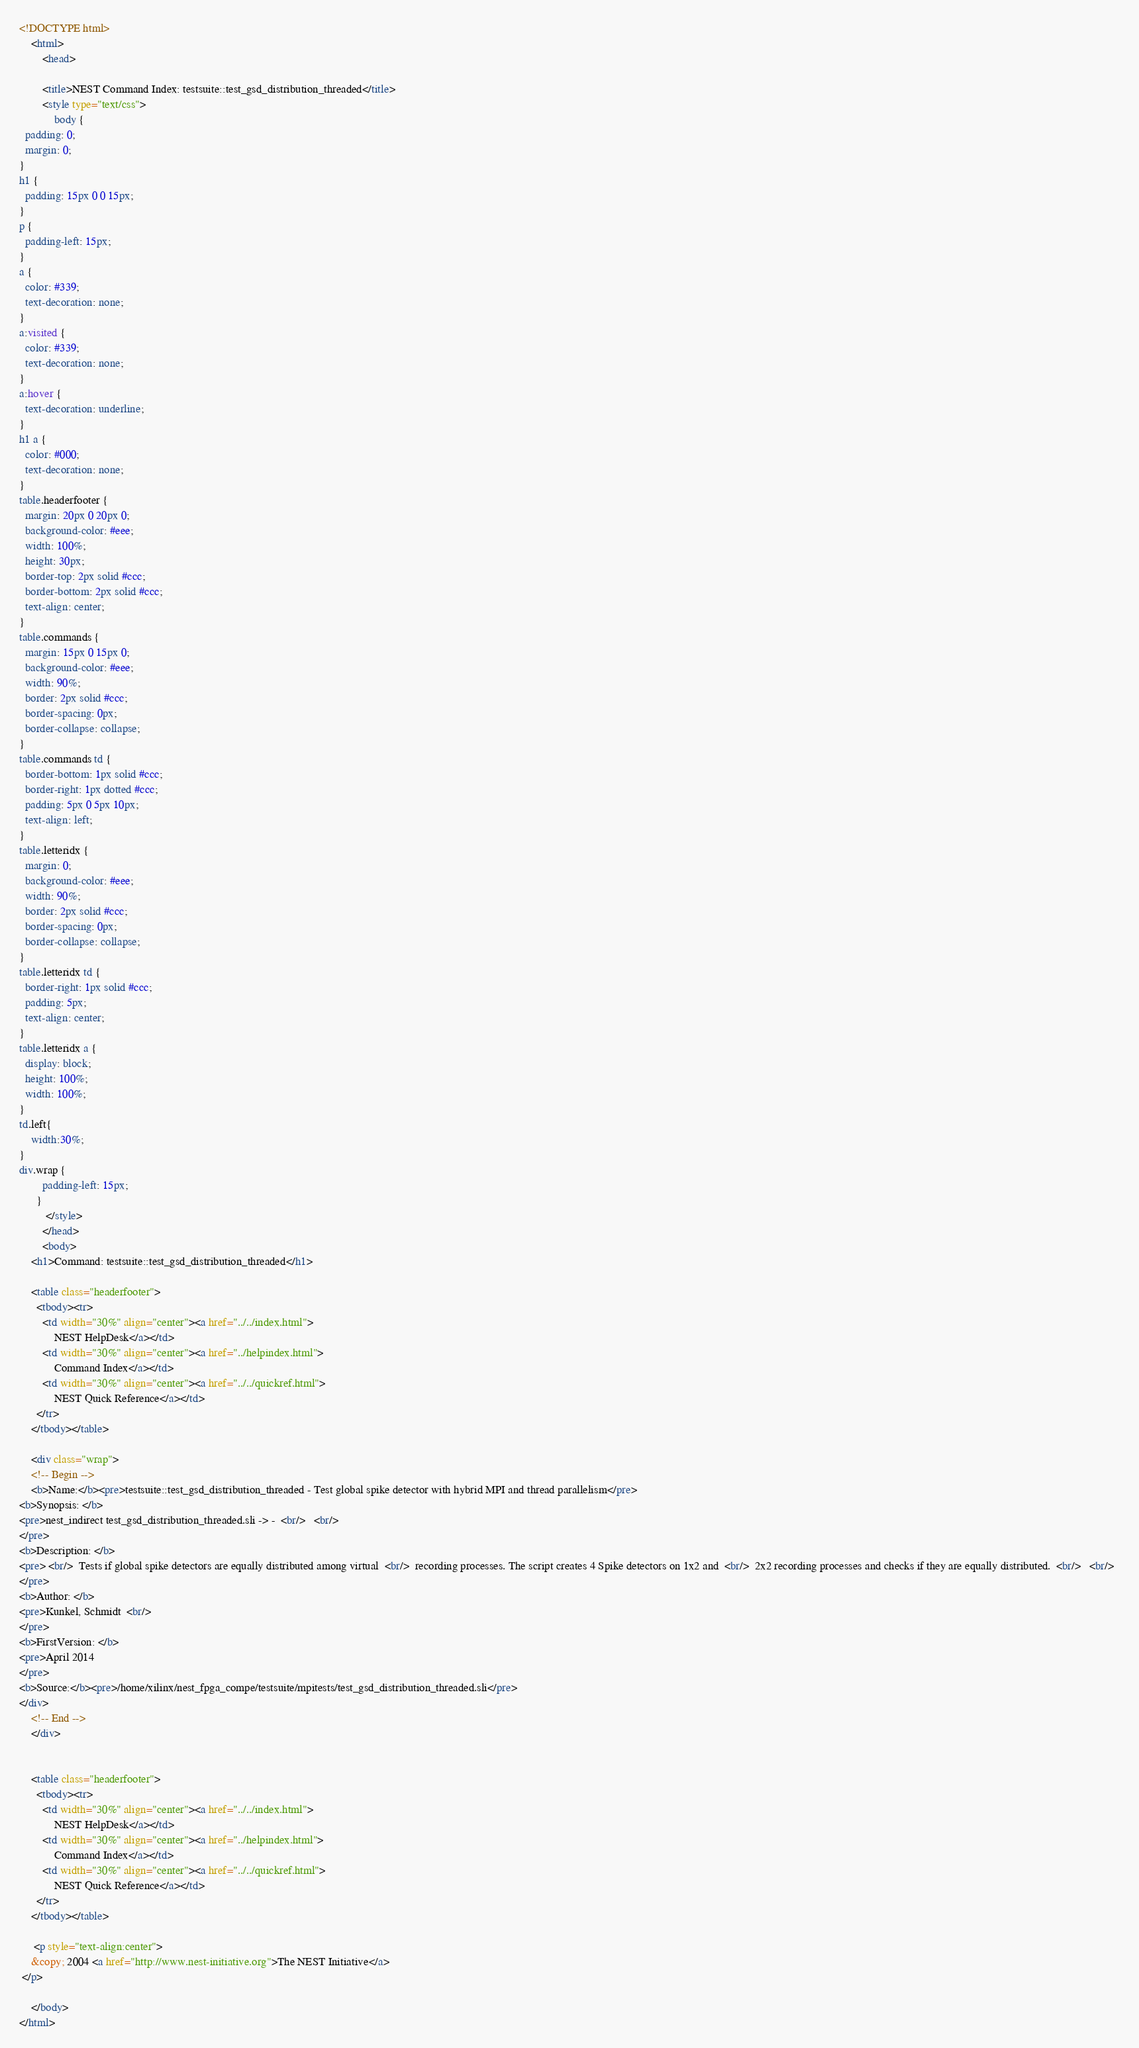Convert code to text. <code><loc_0><loc_0><loc_500><loc_500><_HTML_><!DOCTYPE html>
    <html>
        <head>
    
        <title>NEST Command Index: testsuite::test_gsd_distribution_threaded</title>
        <style type="text/css">
            body {
  padding: 0;
  margin: 0;
}
h1 {
  padding: 15px 0 0 15px;
}
p {
  padding-left: 15px;
}
a {
  color: #339;
  text-decoration: none;
}
a:visited {
  color: #339;
  text-decoration: none;
}
a:hover {
  text-decoration: underline;
}
h1 a {
  color: #000;
  text-decoration: none;
}
table.headerfooter {
  margin: 20px 0 20px 0;
  background-color: #eee;
  width: 100%;
  height: 30px;
  border-top: 2px solid #ccc;
  border-bottom: 2px solid #ccc;
  text-align: center;
}
table.commands {
  margin: 15px 0 15px 0;
  background-color: #eee;
  width: 90%;
  border: 2px solid #ccc;
  border-spacing: 0px;
  border-collapse: collapse;
}
table.commands td {
  border-bottom: 1px solid #ccc;
  border-right: 1px dotted #ccc;
  padding: 5px 0 5px 10px;
  text-align: left;
}
table.letteridx {
  margin: 0;
  background-color: #eee;
  width: 90%;
  border: 2px solid #ccc;
  border-spacing: 0px;
  border-collapse: collapse;
}
table.letteridx td {
  border-right: 1px solid #ccc;
  padding: 5px;
  text-align: center;
}
table.letteridx a {
  display: block;
  height: 100%;
  width: 100%;
}
td.left{
    width:30%;
}
div.wrap {
        padding-left: 15px;
      }
         </style>
        </head>
        <body>
    <h1>Command: testsuite::test_gsd_distribution_threaded</h1>

    <table class="headerfooter">
      <tbody><tr>
        <td width="30%" align="center"><a href="../../index.html">
            NEST HelpDesk</a></td>
        <td width="30%" align="center"><a href="../helpindex.html">
            Command Index</a></td>
        <td width="30%" align="center"><a href="../../quickref.html">
            NEST Quick Reference</a></td>
      </tr>
    </tbody></table>

    <div class="wrap">
    <!-- Begin -->
    <b>Name:</b><pre>testsuite::test_gsd_distribution_threaded - Test global spike detector with hybrid MPI and thread parallelism</pre>
<b>Synopsis: </b>
<pre>nest_indirect test_gsd_distribution_threaded.sli ->	-  <br/>   <br/>  
</pre>
<b>Description: </b>
<pre> <br/>  Tests if global spike detectors are equally distributed among virtual  <br/>  recording processes. The script creates 4 Spike detectors on 1x2 and  <br/>  2x2 recording processes and checks if they are equally distributed.  <br/>   <br/>  
</pre>
<b>Author: </b>
<pre>Kunkel, Schmidt  <br/>  
</pre>
<b>FirstVersion: </b>
<pre>April 2014 
</pre>
<b>Source:</b><pre>/home/xilinx/nest_fpga_compe/testsuite/mpitests/test_gsd_distribution_threaded.sli</pre>
</div>
    <!-- End -->
    </div>


    <table class="headerfooter">
      <tbody><tr>
        <td width="30%" align="center"><a href="../../index.html">
            NEST HelpDesk</a></td>
        <td width="30%" align="center"><a href="../helpindex.html">
            Command Index</a></td>
        <td width="30%" align="center"><a href="../../quickref.html">
            NEST Quick Reference</a></td>
      </tr>
    </tbody></table>

     <p style="text-align:center">
    &copy; 2004 <a href="http://www.nest-initiative.org">The NEST Initiative</a>
 </p>

    </body>
</html></code> 